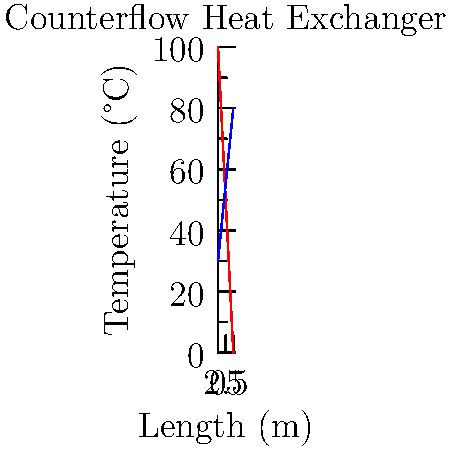In a counterflow heat exchanger, the hot fluid enters at 100°C and exits at 0°C, while the cold fluid enters at 30°C and exits at 80°C. If the heat exchanger is 5 meters long, what is the average temperature gradient (°C/m) for the hot fluid? To find the average temperature gradient for the hot fluid, we need to follow these steps:

1. Determine the total temperature change of the hot fluid:
   $\Delta T_{hot} = T_{in} - T_{out} = 100°C - 0°C = 100°C$

2. Identify the length of the heat exchanger:
   $L = 5$ meters

3. Calculate the average temperature gradient using the formula:
   $\text{Average gradient} = \frac{\text{Temperature change}}{\text{Length}}$

   $\text{Average gradient} = \frac{\Delta T_{hot}}{L} = \frac{100°C}{5m} = 20°C/m$

The negative sign is often used to indicate that the temperature is decreasing along the length of the exchanger, but in this case, we'll report the absolute value.
Answer: 20°C/m 